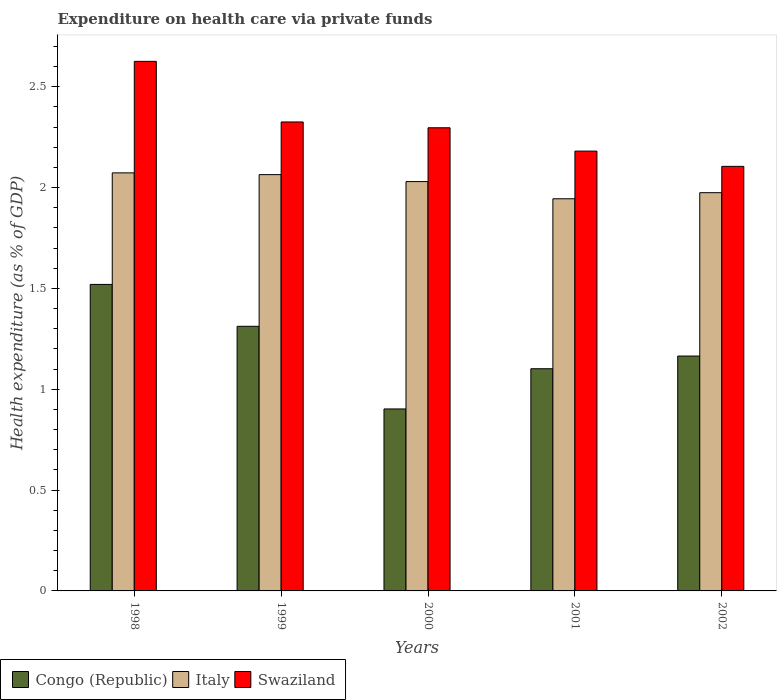What is the expenditure made on health care in Congo (Republic) in 1998?
Keep it short and to the point. 1.52. Across all years, what is the maximum expenditure made on health care in Italy?
Provide a short and direct response. 2.07. Across all years, what is the minimum expenditure made on health care in Italy?
Provide a succinct answer. 1.94. In which year was the expenditure made on health care in Italy maximum?
Your answer should be compact. 1998. What is the total expenditure made on health care in Swaziland in the graph?
Your answer should be very brief. 11.53. What is the difference between the expenditure made on health care in Congo (Republic) in 1998 and that in 2000?
Provide a succinct answer. 0.62. What is the difference between the expenditure made on health care in Swaziland in 2001 and the expenditure made on health care in Congo (Republic) in 2002?
Keep it short and to the point. 1.02. What is the average expenditure made on health care in Congo (Republic) per year?
Provide a succinct answer. 1.2. In the year 1999, what is the difference between the expenditure made on health care in Congo (Republic) and expenditure made on health care in Italy?
Your response must be concise. -0.75. What is the ratio of the expenditure made on health care in Swaziland in 1999 to that in 2002?
Make the answer very short. 1.1. Is the expenditure made on health care in Italy in 1998 less than that in 2000?
Offer a terse response. No. Is the difference between the expenditure made on health care in Congo (Republic) in 1999 and 2000 greater than the difference between the expenditure made on health care in Italy in 1999 and 2000?
Your answer should be very brief. Yes. What is the difference between the highest and the second highest expenditure made on health care in Swaziland?
Give a very brief answer. 0.3. What is the difference between the highest and the lowest expenditure made on health care in Italy?
Give a very brief answer. 0.13. In how many years, is the expenditure made on health care in Italy greater than the average expenditure made on health care in Italy taken over all years?
Make the answer very short. 3. What does the 2nd bar from the left in 1998 represents?
Your answer should be very brief. Italy. What does the 3rd bar from the right in 1998 represents?
Make the answer very short. Congo (Republic). Are all the bars in the graph horizontal?
Offer a terse response. No. Does the graph contain grids?
Your answer should be compact. No. How many legend labels are there?
Keep it short and to the point. 3. How are the legend labels stacked?
Ensure brevity in your answer.  Horizontal. What is the title of the graph?
Your response must be concise. Expenditure on health care via private funds. What is the label or title of the X-axis?
Provide a short and direct response. Years. What is the label or title of the Y-axis?
Your response must be concise. Health expenditure (as % of GDP). What is the Health expenditure (as % of GDP) in Congo (Republic) in 1998?
Provide a succinct answer. 1.52. What is the Health expenditure (as % of GDP) of Italy in 1998?
Keep it short and to the point. 2.07. What is the Health expenditure (as % of GDP) in Swaziland in 1998?
Your answer should be very brief. 2.63. What is the Health expenditure (as % of GDP) in Congo (Republic) in 1999?
Offer a very short reply. 1.31. What is the Health expenditure (as % of GDP) of Italy in 1999?
Provide a short and direct response. 2.06. What is the Health expenditure (as % of GDP) of Swaziland in 1999?
Your answer should be compact. 2.33. What is the Health expenditure (as % of GDP) in Congo (Republic) in 2000?
Ensure brevity in your answer.  0.9. What is the Health expenditure (as % of GDP) of Italy in 2000?
Provide a succinct answer. 2.03. What is the Health expenditure (as % of GDP) of Swaziland in 2000?
Offer a very short reply. 2.3. What is the Health expenditure (as % of GDP) of Congo (Republic) in 2001?
Your answer should be very brief. 1.1. What is the Health expenditure (as % of GDP) of Italy in 2001?
Your response must be concise. 1.94. What is the Health expenditure (as % of GDP) of Swaziland in 2001?
Your answer should be very brief. 2.18. What is the Health expenditure (as % of GDP) in Congo (Republic) in 2002?
Provide a succinct answer. 1.16. What is the Health expenditure (as % of GDP) in Italy in 2002?
Your response must be concise. 1.97. What is the Health expenditure (as % of GDP) in Swaziland in 2002?
Make the answer very short. 2.11. Across all years, what is the maximum Health expenditure (as % of GDP) of Congo (Republic)?
Offer a very short reply. 1.52. Across all years, what is the maximum Health expenditure (as % of GDP) in Italy?
Offer a very short reply. 2.07. Across all years, what is the maximum Health expenditure (as % of GDP) of Swaziland?
Keep it short and to the point. 2.63. Across all years, what is the minimum Health expenditure (as % of GDP) in Congo (Republic)?
Give a very brief answer. 0.9. Across all years, what is the minimum Health expenditure (as % of GDP) in Italy?
Give a very brief answer. 1.94. Across all years, what is the minimum Health expenditure (as % of GDP) in Swaziland?
Provide a short and direct response. 2.11. What is the total Health expenditure (as % of GDP) in Congo (Republic) in the graph?
Offer a terse response. 6. What is the total Health expenditure (as % of GDP) of Italy in the graph?
Keep it short and to the point. 10.09. What is the total Health expenditure (as % of GDP) in Swaziland in the graph?
Provide a succinct answer. 11.54. What is the difference between the Health expenditure (as % of GDP) of Congo (Republic) in 1998 and that in 1999?
Offer a very short reply. 0.21. What is the difference between the Health expenditure (as % of GDP) of Italy in 1998 and that in 1999?
Offer a terse response. 0.01. What is the difference between the Health expenditure (as % of GDP) in Swaziland in 1998 and that in 1999?
Give a very brief answer. 0.3. What is the difference between the Health expenditure (as % of GDP) in Congo (Republic) in 1998 and that in 2000?
Offer a very short reply. 0.62. What is the difference between the Health expenditure (as % of GDP) in Italy in 1998 and that in 2000?
Give a very brief answer. 0.04. What is the difference between the Health expenditure (as % of GDP) of Swaziland in 1998 and that in 2000?
Provide a succinct answer. 0.33. What is the difference between the Health expenditure (as % of GDP) in Congo (Republic) in 1998 and that in 2001?
Provide a short and direct response. 0.42. What is the difference between the Health expenditure (as % of GDP) of Italy in 1998 and that in 2001?
Keep it short and to the point. 0.13. What is the difference between the Health expenditure (as % of GDP) in Swaziland in 1998 and that in 2001?
Make the answer very short. 0.45. What is the difference between the Health expenditure (as % of GDP) of Congo (Republic) in 1998 and that in 2002?
Give a very brief answer. 0.36. What is the difference between the Health expenditure (as % of GDP) in Italy in 1998 and that in 2002?
Your answer should be very brief. 0.1. What is the difference between the Health expenditure (as % of GDP) in Swaziland in 1998 and that in 2002?
Your answer should be very brief. 0.52. What is the difference between the Health expenditure (as % of GDP) in Congo (Republic) in 1999 and that in 2000?
Make the answer very short. 0.41. What is the difference between the Health expenditure (as % of GDP) of Italy in 1999 and that in 2000?
Give a very brief answer. 0.03. What is the difference between the Health expenditure (as % of GDP) in Swaziland in 1999 and that in 2000?
Ensure brevity in your answer.  0.03. What is the difference between the Health expenditure (as % of GDP) in Congo (Republic) in 1999 and that in 2001?
Offer a terse response. 0.21. What is the difference between the Health expenditure (as % of GDP) in Italy in 1999 and that in 2001?
Keep it short and to the point. 0.12. What is the difference between the Health expenditure (as % of GDP) of Swaziland in 1999 and that in 2001?
Provide a succinct answer. 0.14. What is the difference between the Health expenditure (as % of GDP) of Congo (Republic) in 1999 and that in 2002?
Make the answer very short. 0.15. What is the difference between the Health expenditure (as % of GDP) in Italy in 1999 and that in 2002?
Offer a terse response. 0.09. What is the difference between the Health expenditure (as % of GDP) in Swaziland in 1999 and that in 2002?
Offer a very short reply. 0.22. What is the difference between the Health expenditure (as % of GDP) in Congo (Republic) in 2000 and that in 2001?
Ensure brevity in your answer.  -0.2. What is the difference between the Health expenditure (as % of GDP) in Italy in 2000 and that in 2001?
Offer a terse response. 0.09. What is the difference between the Health expenditure (as % of GDP) in Swaziland in 2000 and that in 2001?
Make the answer very short. 0.12. What is the difference between the Health expenditure (as % of GDP) in Congo (Republic) in 2000 and that in 2002?
Your answer should be very brief. -0.26. What is the difference between the Health expenditure (as % of GDP) in Italy in 2000 and that in 2002?
Offer a very short reply. 0.06. What is the difference between the Health expenditure (as % of GDP) in Swaziland in 2000 and that in 2002?
Make the answer very short. 0.19. What is the difference between the Health expenditure (as % of GDP) of Congo (Republic) in 2001 and that in 2002?
Keep it short and to the point. -0.06. What is the difference between the Health expenditure (as % of GDP) in Italy in 2001 and that in 2002?
Offer a terse response. -0.03. What is the difference between the Health expenditure (as % of GDP) in Swaziland in 2001 and that in 2002?
Provide a short and direct response. 0.08. What is the difference between the Health expenditure (as % of GDP) of Congo (Republic) in 1998 and the Health expenditure (as % of GDP) of Italy in 1999?
Provide a succinct answer. -0.54. What is the difference between the Health expenditure (as % of GDP) of Congo (Republic) in 1998 and the Health expenditure (as % of GDP) of Swaziland in 1999?
Keep it short and to the point. -0.81. What is the difference between the Health expenditure (as % of GDP) in Italy in 1998 and the Health expenditure (as % of GDP) in Swaziland in 1999?
Your response must be concise. -0.25. What is the difference between the Health expenditure (as % of GDP) in Congo (Republic) in 1998 and the Health expenditure (as % of GDP) in Italy in 2000?
Provide a succinct answer. -0.51. What is the difference between the Health expenditure (as % of GDP) in Congo (Republic) in 1998 and the Health expenditure (as % of GDP) in Swaziland in 2000?
Keep it short and to the point. -0.78. What is the difference between the Health expenditure (as % of GDP) of Italy in 1998 and the Health expenditure (as % of GDP) of Swaziland in 2000?
Keep it short and to the point. -0.22. What is the difference between the Health expenditure (as % of GDP) in Congo (Republic) in 1998 and the Health expenditure (as % of GDP) in Italy in 2001?
Provide a succinct answer. -0.42. What is the difference between the Health expenditure (as % of GDP) in Congo (Republic) in 1998 and the Health expenditure (as % of GDP) in Swaziland in 2001?
Your response must be concise. -0.66. What is the difference between the Health expenditure (as % of GDP) of Italy in 1998 and the Health expenditure (as % of GDP) of Swaziland in 2001?
Your answer should be very brief. -0.11. What is the difference between the Health expenditure (as % of GDP) of Congo (Republic) in 1998 and the Health expenditure (as % of GDP) of Italy in 2002?
Your answer should be very brief. -0.45. What is the difference between the Health expenditure (as % of GDP) of Congo (Republic) in 1998 and the Health expenditure (as % of GDP) of Swaziland in 2002?
Your response must be concise. -0.59. What is the difference between the Health expenditure (as % of GDP) of Italy in 1998 and the Health expenditure (as % of GDP) of Swaziland in 2002?
Your answer should be compact. -0.03. What is the difference between the Health expenditure (as % of GDP) in Congo (Republic) in 1999 and the Health expenditure (as % of GDP) in Italy in 2000?
Your answer should be compact. -0.72. What is the difference between the Health expenditure (as % of GDP) of Congo (Republic) in 1999 and the Health expenditure (as % of GDP) of Swaziland in 2000?
Offer a terse response. -0.98. What is the difference between the Health expenditure (as % of GDP) in Italy in 1999 and the Health expenditure (as % of GDP) in Swaziland in 2000?
Make the answer very short. -0.23. What is the difference between the Health expenditure (as % of GDP) of Congo (Republic) in 1999 and the Health expenditure (as % of GDP) of Italy in 2001?
Give a very brief answer. -0.63. What is the difference between the Health expenditure (as % of GDP) in Congo (Republic) in 1999 and the Health expenditure (as % of GDP) in Swaziland in 2001?
Your answer should be very brief. -0.87. What is the difference between the Health expenditure (as % of GDP) of Italy in 1999 and the Health expenditure (as % of GDP) of Swaziland in 2001?
Offer a very short reply. -0.12. What is the difference between the Health expenditure (as % of GDP) in Congo (Republic) in 1999 and the Health expenditure (as % of GDP) in Italy in 2002?
Keep it short and to the point. -0.66. What is the difference between the Health expenditure (as % of GDP) of Congo (Republic) in 1999 and the Health expenditure (as % of GDP) of Swaziland in 2002?
Your answer should be compact. -0.79. What is the difference between the Health expenditure (as % of GDP) of Italy in 1999 and the Health expenditure (as % of GDP) of Swaziland in 2002?
Provide a succinct answer. -0.04. What is the difference between the Health expenditure (as % of GDP) in Congo (Republic) in 2000 and the Health expenditure (as % of GDP) in Italy in 2001?
Make the answer very short. -1.04. What is the difference between the Health expenditure (as % of GDP) in Congo (Republic) in 2000 and the Health expenditure (as % of GDP) in Swaziland in 2001?
Provide a succinct answer. -1.28. What is the difference between the Health expenditure (as % of GDP) of Italy in 2000 and the Health expenditure (as % of GDP) of Swaziland in 2001?
Your answer should be very brief. -0.15. What is the difference between the Health expenditure (as % of GDP) of Congo (Republic) in 2000 and the Health expenditure (as % of GDP) of Italy in 2002?
Give a very brief answer. -1.07. What is the difference between the Health expenditure (as % of GDP) in Congo (Republic) in 2000 and the Health expenditure (as % of GDP) in Swaziland in 2002?
Your answer should be compact. -1.2. What is the difference between the Health expenditure (as % of GDP) of Italy in 2000 and the Health expenditure (as % of GDP) of Swaziland in 2002?
Keep it short and to the point. -0.08. What is the difference between the Health expenditure (as % of GDP) in Congo (Republic) in 2001 and the Health expenditure (as % of GDP) in Italy in 2002?
Give a very brief answer. -0.87. What is the difference between the Health expenditure (as % of GDP) of Congo (Republic) in 2001 and the Health expenditure (as % of GDP) of Swaziland in 2002?
Give a very brief answer. -1. What is the difference between the Health expenditure (as % of GDP) of Italy in 2001 and the Health expenditure (as % of GDP) of Swaziland in 2002?
Offer a very short reply. -0.16. What is the average Health expenditure (as % of GDP) in Congo (Republic) per year?
Your answer should be very brief. 1.2. What is the average Health expenditure (as % of GDP) of Italy per year?
Provide a succinct answer. 2.02. What is the average Health expenditure (as % of GDP) in Swaziland per year?
Provide a short and direct response. 2.31. In the year 1998, what is the difference between the Health expenditure (as % of GDP) in Congo (Republic) and Health expenditure (as % of GDP) in Italy?
Your answer should be compact. -0.55. In the year 1998, what is the difference between the Health expenditure (as % of GDP) in Congo (Republic) and Health expenditure (as % of GDP) in Swaziland?
Ensure brevity in your answer.  -1.11. In the year 1998, what is the difference between the Health expenditure (as % of GDP) in Italy and Health expenditure (as % of GDP) in Swaziland?
Offer a very short reply. -0.55. In the year 1999, what is the difference between the Health expenditure (as % of GDP) of Congo (Republic) and Health expenditure (as % of GDP) of Italy?
Keep it short and to the point. -0.75. In the year 1999, what is the difference between the Health expenditure (as % of GDP) of Congo (Republic) and Health expenditure (as % of GDP) of Swaziland?
Your answer should be very brief. -1.01. In the year 1999, what is the difference between the Health expenditure (as % of GDP) of Italy and Health expenditure (as % of GDP) of Swaziland?
Ensure brevity in your answer.  -0.26. In the year 2000, what is the difference between the Health expenditure (as % of GDP) of Congo (Republic) and Health expenditure (as % of GDP) of Italy?
Ensure brevity in your answer.  -1.13. In the year 2000, what is the difference between the Health expenditure (as % of GDP) in Congo (Republic) and Health expenditure (as % of GDP) in Swaziland?
Offer a very short reply. -1.39. In the year 2000, what is the difference between the Health expenditure (as % of GDP) of Italy and Health expenditure (as % of GDP) of Swaziland?
Make the answer very short. -0.27. In the year 2001, what is the difference between the Health expenditure (as % of GDP) of Congo (Republic) and Health expenditure (as % of GDP) of Italy?
Offer a terse response. -0.84. In the year 2001, what is the difference between the Health expenditure (as % of GDP) in Congo (Republic) and Health expenditure (as % of GDP) in Swaziland?
Give a very brief answer. -1.08. In the year 2001, what is the difference between the Health expenditure (as % of GDP) of Italy and Health expenditure (as % of GDP) of Swaziland?
Your answer should be very brief. -0.24. In the year 2002, what is the difference between the Health expenditure (as % of GDP) of Congo (Republic) and Health expenditure (as % of GDP) of Italy?
Offer a very short reply. -0.81. In the year 2002, what is the difference between the Health expenditure (as % of GDP) of Congo (Republic) and Health expenditure (as % of GDP) of Swaziland?
Provide a succinct answer. -0.94. In the year 2002, what is the difference between the Health expenditure (as % of GDP) of Italy and Health expenditure (as % of GDP) of Swaziland?
Provide a succinct answer. -0.13. What is the ratio of the Health expenditure (as % of GDP) in Congo (Republic) in 1998 to that in 1999?
Keep it short and to the point. 1.16. What is the ratio of the Health expenditure (as % of GDP) of Italy in 1998 to that in 1999?
Your answer should be compact. 1. What is the ratio of the Health expenditure (as % of GDP) of Swaziland in 1998 to that in 1999?
Provide a short and direct response. 1.13. What is the ratio of the Health expenditure (as % of GDP) of Congo (Republic) in 1998 to that in 2000?
Offer a very short reply. 1.68. What is the ratio of the Health expenditure (as % of GDP) in Italy in 1998 to that in 2000?
Make the answer very short. 1.02. What is the ratio of the Health expenditure (as % of GDP) in Swaziland in 1998 to that in 2000?
Offer a terse response. 1.14. What is the ratio of the Health expenditure (as % of GDP) of Congo (Republic) in 1998 to that in 2001?
Offer a terse response. 1.38. What is the ratio of the Health expenditure (as % of GDP) of Italy in 1998 to that in 2001?
Offer a very short reply. 1.07. What is the ratio of the Health expenditure (as % of GDP) in Swaziland in 1998 to that in 2001?
Offer a very short reply. 1.2. What is the ratio of the Health expenditure (as % of GDP) of Congo (Republic) in 1998 to that in 2002?
Provide a succinct answer. 1.3. What is the ratio of the Health expenditure (as % of GDP) in Italy in 1998 to that in 2002?
Keep it short and to the point. 1.05. What is the ratio of the Health expenditure (as % of GDP) of Swaziland in 1998 to that in 2002?
Your answer should be very brief. 1.25. What is the ratio of the Health expenditure (as % of GDP) of Congo (Republic) in 1999 to that in 2000?
Your answer should be very brief. 1.45. What is the ratio of the Health expenditure (as % of GDP) in Italy in 1999 to that in 2000?
Provide a short and direct response. 1.02. What is the ratio of the Health expenditure (as % of GDP) in Swaziland in 1999 to that in 2000?
Your answer should be compact. 1.01. What is the ratio of the Health expenditure (as % of GDP) in Congo (Republic) in 1999 to that in 2001?
Your answer should be very brief. 1.19. What is the ratio of the Health expenditure (as % of GDP) of Italy in 1999 to that in 2001?
Provide a succinct answer. 1.06. What is the ratio of the Health expenditure (as % of GDP) in Swaziland in 1999 to that in 2001?
Offer a terse response. 1.07. What is the ratio of the Health expenditure (as % of GDP) of Congo (Republic) in 1999 to that in 2002?
Keep it short and to the point. 1.13. What is the ratio of the Health expenditure (as % of GDP) of Italy in 1999 to that in 2002?
Provide a succinct answer. 1.05. What is the ratio of the Health expenditure (as % of GDP) of Swaziland in 1999 to that in 2002?
Ensure brevity in your answer.  1.1. What is the ratio of the Health expenditure (as % of GDP) of Congo (Republic) in 2000 to that in 2001?
Your answer should be compact. 0.82. What is the ratio of the Health expenditure (as % of GDP) in Italy in 2000 to that in 2001?
Provide a short and direct response. 1.04. What is the ratio of the Health expenditure (as % of GDP) of Swaziland in 2000 to that in 2001?
Make the answer very short. 1.05. What is the ratio of the Health expenditure (as % of GDP) in Congo (Republic) in 2000 to that in 2002?
Offer a terse response. 0.77. What is the ratio of the Health expenditure (as % of GDP) in Italy in 2000 to that in 2002?
Your answer should be compact. 1.03. What is the ratio of the Health expenditure (as % of GDP) in Congo (Republic) in 2001 to that in 2002?
Make the answer very short. 0.95. What is the ratio of the Health expenditure (as % of GDP) of Italy in 2001 to that in 2002?
Your response must be concise. 0.98. What is the ratio of the Health expenditure (as % of GDP) of Swaziland in 2001 to that in 2002?
Provide a succinct answer. 1.04. What is the difference between the highest and the second highest Health expenditure (as % of GDP) in Congo (Republic)?
Provide a succinct answer. 0.21. What is the difference between the highest and the second highest Health expenditure (as % of GDP) in Italy?
Your answer should be compact. 0.01. What is the difference between the highest and the second highest Health expenditure (as % of GDP) of Swaziland?
Give a very brief answer. 0.3. What is the difference between the highest and the lowest Health expenditure (as % of GDP) of Congo (Republic)?
Offer a very short reply. 0.62. What is the difference between the highest and the lowest Health expenditure (as % of GDP) of Italy?
Your answer should be very brief. 0.13. What is the difference between the highest and the lowest Health expenditure (as % of GDP) of Swaziland?
Offer a terse response. 0.52. 